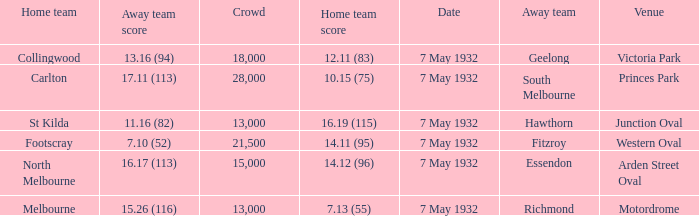What is the home team for victoria park? Collingwood. 